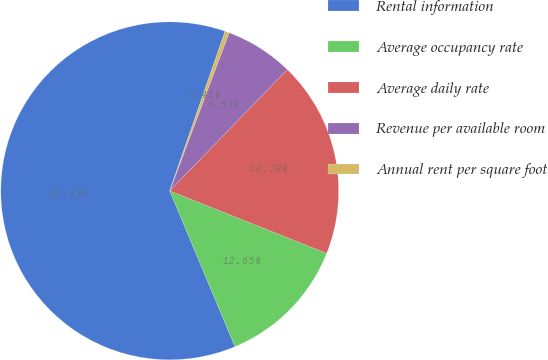<chart> <loc_0><loc_0><loc_500><loc_500><pie_chart><fcel>Rental information<fcel>Average occupancy rate<fcel>Average daily rate<fcel>Revenue per available room<fcel>Annual rent per square foot<nl><fcel>61.63%<fcel>12.65%<fcel>18.78%<fcel>6.53%<fcel>0.41%<nl></chart> 